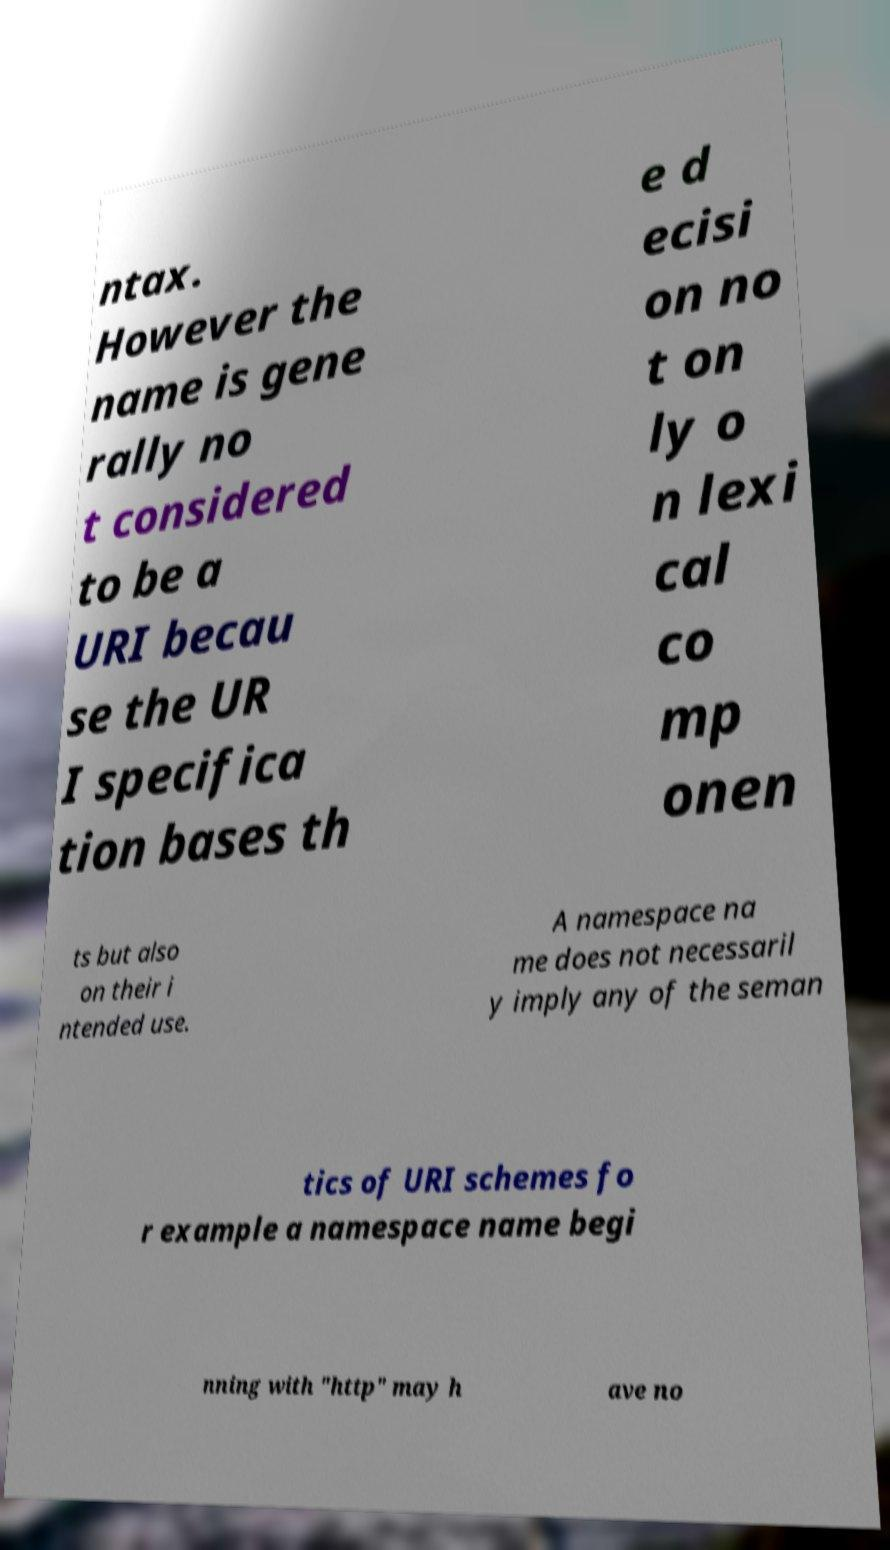Could you assist in decoding the text presented in this image and type it out clearly? ntax. However the name is gene rally no t considered to be a URI becau se the UR I specifica tion bases th e d ecisi on no t on ly o n lexi cal co mp onen ts but also on their i ntended use. A namespace na me does not necessaril y imply any of the seman tics of URI schemes fo r example a namespace name begi nning with "http" may h ave no 